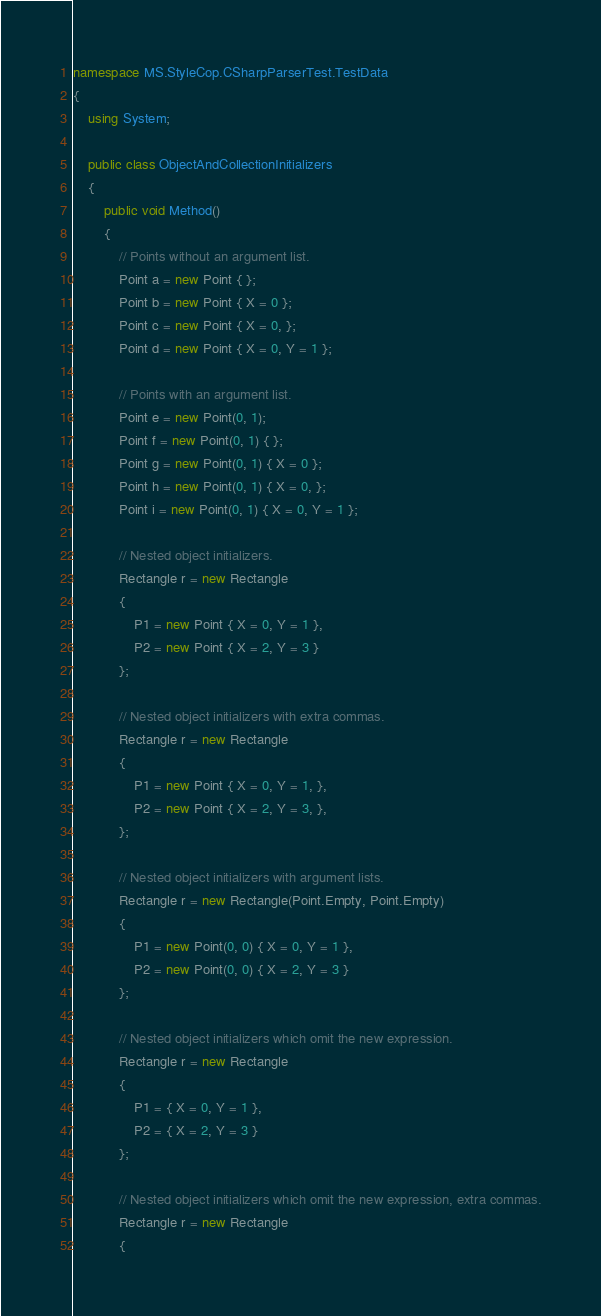Convert code to text. <code><loc_0><loc_0><loc_500><loc_500><_C#_>namespace MS.StyleCop.CSharpParserTest.TestData
{
    using System;

    public class ObjectAndCollectionInitializers
    {
        public void Method()
        {
            // Points without an argument list.
            Point a = new Point { };
            Point b = new Point { X = 0 };
            Point c = new Point { X = 0, };
            Point d = new Point { X = 0, Y = 1 };

            // Points with an argument list.
            Point e = new Point(0, 1);
            Point f = new Point(0, 1) { };
            Point g = new Point(0, 1) { X = 0 };
            Point h = new Point(0, 1) { X = 0, };
            Point i = new Point(0, 1) { X = 0, Y = 1 };

            // Nested object initializers.
            Rectangle r = new Rectangle
            {
                P1 = new Point { X = 0, Y = 1 },
                P2 = new Point { X = 2, Y = 3 }
            };

            // Nested object initializers with extra commas.
            Rectangle r = new Rectangle
            {
                P1 = new Point { X = 0, Y = 1, },
                P2 = new Point { X = 2, Y = 3, },
            };

            // Nested object initializers with argument lists.
            Rectangle r = new Rectangle(Point.Empty, Point.Empty)
            {
                P1 = new Point(0, 0) { X = 0, Y = 1 },
                P2 = new Point(0, 0) { X = 2, Y = 3 }
            };

            // Nested object initializers which omit the new expression.
            Rectangle r = new Rectangle
            {
                P1 = { X = 0, Y = 1 },
                P2 = { X = 2, Y = 3 }
            };

            // Nested object initializers which omit the new expression, extra commas.
            Rectangle r = new Rectangle
            {</code> 